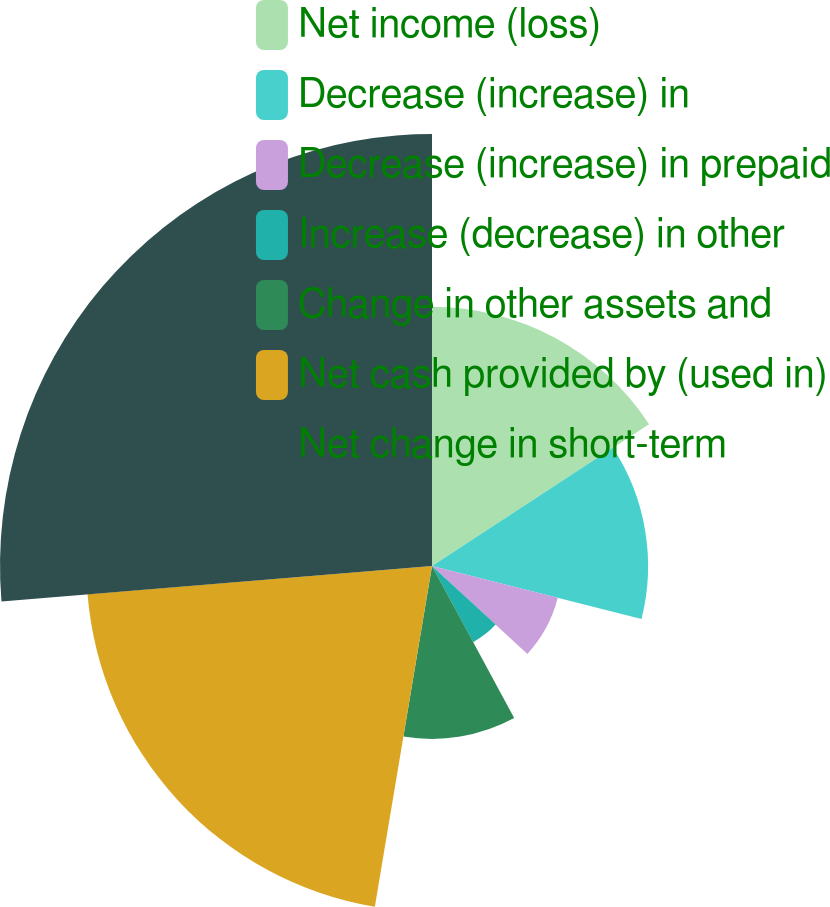Convert chart. <chart><loc_0><loc_0><loc_500><loc_500><pie_chart><fcel>Net income (loss)<fcel>Decrease (increase) in<fcel>Decrease (increase) in prepaid<fcel>Increase (decrease) in other<fcel>Change in other assets and<fcel>Net cash provided by (used in)<fcel>Net change in short-term<nl><fcel>15.79%<fcel>13.16%<fcel>7.9%<fcel>5.27%<fcel>10.53%<fcel>21.05%<fcel>26.31%<nl></chart> 